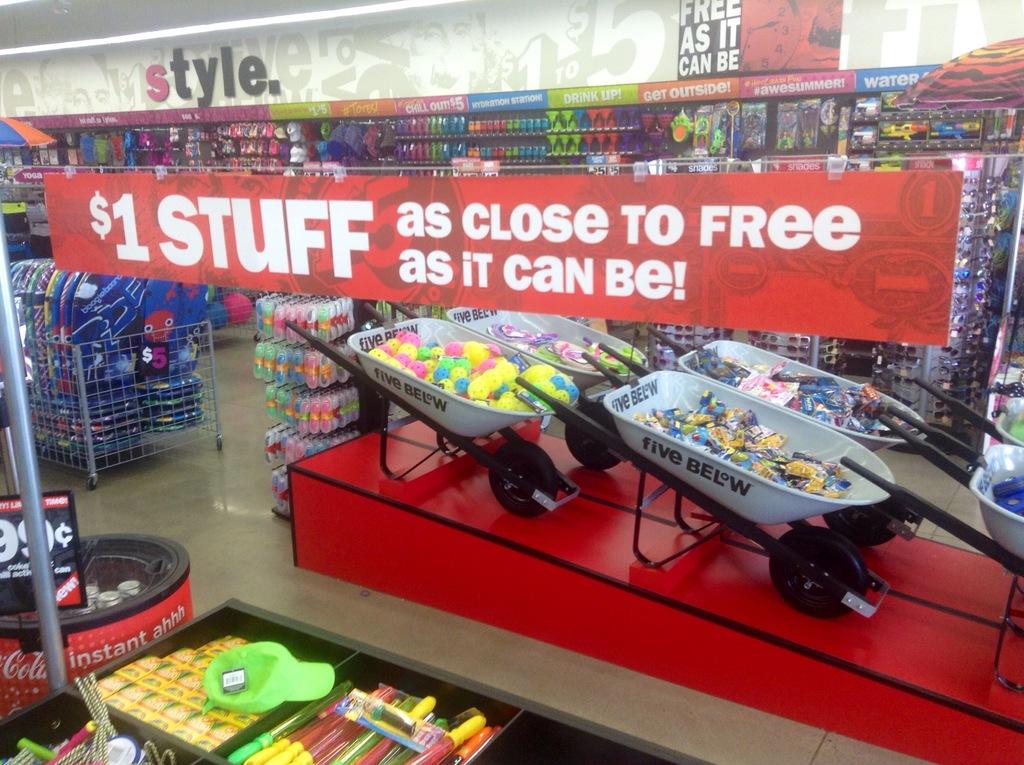What does the red banner say?
Keep it short and to the point. $1 stuff as close to free as it can be!. How much do the items under the red banner cost?
Offer a terse response. $1. 